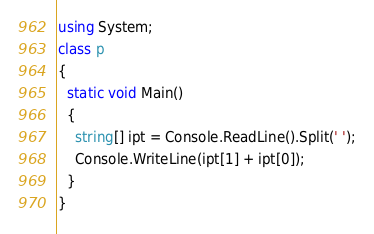<code> <loc_0><loc_0><loc_500><loc_500><_C#_>using System;
class p
{
  static void Main()
  {
    string[] ipt = Console.ReadLine().Split(' ');
    Console.WriteLine(ipt[1] + ipt[0]);
  }
}</code> 